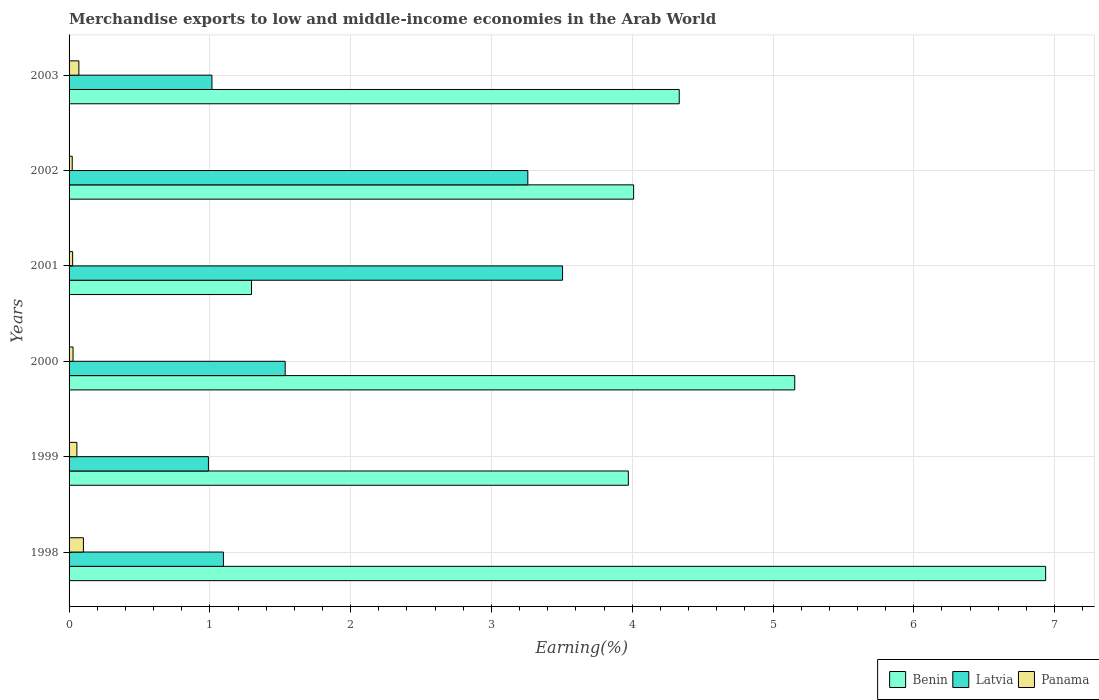Are the number of bars per tick equal to the number of legend labels?
Your answer should be compact. Yes. How many bars are there on the 6th tick from the top?
Offer a very short reply. 3. How many bars are there on the 2nd tick from the bottom?
Keep it short and to the point. 3. In how many cases, is the number of bars for a given year not equal to the number of legend labels?
Offer a terse response. 0. What is the percentage of amount earned from merchandise exports in Latvia in 2003?
Offer a terse response. 1.01. Across all years, what is the maximum percentage of amount earned from merchandise exports in Latvia?
Make the answer very short. 3.51. Across all years, what is the minimum percentage of amount earned from merchandise exports in Latvia?
Your answer should be very brief. 0.99. In which year was the percentage of amount earned from merchandise exports in Benin maximum?
Give a very brief answer. 1998. What is the total percentage of amount earned from merchandise exports in Panama in the graph?
Ensure brevity in your answer.  0.3. What is the difference between the percentage of amount earned from merchandise exports in Latvia in 2000 and that in 2002?
Ensure brevity in your answer.  -1.72. What is the difference between the percentage of amount earned from merchandise exports in Benin in 1999 and the percentage of amount earned from merchandise exports in Panama in 2003?
Ensure brevity in your answer.  3.9. What is the average percentage of amount earned from merchandise exports in Panama per year?
Provide a succinct answer. 0.05. In the year 2002, what is the difference between the percentage of amount earned from merchandise exports in Benin and percentage of amount earned from merchandise exports in Latvia?
Provide a short and direct response. 0.75. In how many years, is the percentage of amount earned from merchandise exports in Latvia greater than 4 %?
Your response must be concise. 0. What is the ratio of the percentage of amount earned from merchandise exports in Benin in 2000 to that in 2001?
Offer a very short reply. 3.98. What is the difference between the highest and the second highest percentage of amount earned from merchandise exports in Benin?
Provide a succinct answer. 1.78. What is the difference between the highest and the lowest percentage of amount earned from merchandise exports in Latvia?
Offer a terse response. 2.52. Is the sum of the percentage of amount earned from merchandise exports in Latvia in 1999 and 2002 greater than the maximum percentage of amount earned from merchandise exports in Benin across all years?
Your answer should be very brief. No. What does the 1st bar from the top in 2003 represents?
Make the answer very short. Panama. What does the 1st bar from the bottom in 2002 represents?
Your answer should be compact. Benin. Is it the case that in every year, the sum of the percentage of amount earned from merchandise exports in Panama and percentage of amount earned from merchandise exports in Benin is greater than the percentage of amount earned from merchandise exports in Latvia?
Your response must be concise. No. How many bars are there?
Make the answer very short. 18. Are all the bars in the graph horizontal?
Offer a terse response. Yes. How many years are there in the graph?
Provide a short and direct response. 6. Where does the legend appear in the graph?
Ensure brevity in your answer.  Bottom right. What is the title of the graph?
Give a very brief answer. Merchandise exports to low and middle-income economies in the Arab World. Does "Madagascar" appear as one of the legend labels in the graph?
Offer a very short reply. No. What is the label or title of the X-axis?
Offer a very short reply. Earning(%). What is the Earning(%) in Benin in 1998?
Your answer should be compact. 6.94. What is the Earning(%) in Latvia in 1998?
Your response must be concise. 1.1. What is the Earning(%) in Panama in 1998?
Ensure brevity in your answer.  0.1. What is the Earning(%) of Benin in 1999?
Provide a short and direct response. 3.97. What is the Earning(%) in Latvia in 1999?
Your answer should be very brief. 0.99. What is the Earning(%) in Panama in 1999?
Offer a terse response. 0.06. What is the Earning(%) in Benin in 2000?
Provide a succinct answer. 5.15. What is the Earning(%) of Latvia in 2000?
Your response must be concise. 1.54. What is the Earning(%) of Panama in 2000?
Make the answer very short. 0.03. What is the Earning(%) of Benin in 2001?
Your answer should be compact. 1.3. What is the Earning(%) in Latvia in 2001?
Provide a succinct answer. 3.51. What is the Earning(%) of Panama in 2001?
Give a very brief answer. 0.03. What is the Earning(%) in Benin in 2002?
Your answer should be very brief. 4.01. What is the Earning(%) of Latvia in 2002?
Provide a succinct answer. 3.26. What is the Earning(%) in Panama in 2002?
Keep it short and to the point. 0.02. What is the Earning(%) in Benin in 2003?
Make the answer very short. 4.33. What is the Earning(%) of Latvia in 2003?
Keep it short and to the point. 1.01. What is the Earning(%) of Panama in 2003?
Your answer should be very brief. 0.07. Across all years, what is the maximum Earning(%) in Benin?
Keep it short and to the point. 6.94. Across all years, what is the maximum Earning(%) in Latvia?
Your response must be concise. 3.51. Across all years, what is the maximum Earning(%) in Panama?
Make the answer very short. 0.1. Across all years, what is the minimum Earning(%) of Benin?
Give a very brief answer. 1.3. Across all years, what is the minimum Earning(%) of Latvia?
Provide a short and direct response. 0.99. Across all years, what is the minimum Earning(%) in Panama?
Make the answer very short. 0.02. What is the total Earning(%) of Benin in the graph?
Ensure brevity in your answer.  25.7. What is the total Earning(%) of Latvia in the graph?
Offer a terse response. 11.4. What is the total Earning(%) in Panama in the graph?
Offer a terse response. 0.3. What is the difference between the Earning(%) in Benin in 1998 and that in 1999?
Your answer should be compact. 2.96. What is the difference between the Earning(%) in Latvia in 1998 and that in 1999?
Ensure brevity in your answer.  0.11. What is the difference between the Earning(%) of Panama in 1998 and that in 1999?
Your answer should be compact. 0.05. What is the difference between the Earning(%) of Benin in 1998 and that in 2000?
Keep it short and to the point. 1.78. What is the difference between the Earning(%) in Latvia in 1998 and that in 2000?
Your answer should be compact. -0.44. What is the difference between the Earning(%) of Panama in 1998 and that in 2000?
Provide a short and direct response. 0.07. What is the difference between the Earning(%) in Benin in 1998 and that in 2001?
Your answer should be very brief. 5.64. What is the difference between the Earning(%) of Latvia in 1998 and that in 2001?
Give a very brief answer. -2.41. What is the difference between the Earning(%) of Panama in 1998 and that in 2001?
Your answer should be very brief. 0.08. What is the difference between the Earning(%) in Benin in 1998 and that in 2002?
Your response must be concise. 2.93. What is the difference between the Earning(%) of Latvia in 1998 and that in 2002?
Offer a terse response. -2.16. What is the difference between the Earning(%) of Panama in 1998 and that in 2002?
Your answer should be very brief. 0.08. What is the difference between the Earning(%) in Benin in 1998 and that in 2003?
Provide a short and direct response. 2.6. What is the difference between the Earning(%) of Latvia in 1998 and that in 2003?
Ensure brevity in your answer.  0.08. What is the difference between the Earning(%) in Panama in 1998 and that in 2003?
Offer a terse response. 0.03. What is the difference between the Earning(%) of Benin in 1999 and that in 2000?
Your response must be concise. -1.18. What is the difference between the Earning(%) in Latvia in 1999 and that in 2000?
Keep it short and to the point. -0.55. What is the difference between the Earning(%) in Panama in 1999 and that in 2000?
Your response must be concise. 0.03. What is the difference between the Earning(%) of Benin in 1999 and that in 2001?
Your answer should be very brief. 2.68. What is the difference between the Earning(%) of Latvia in 1999 and that in 2001?
Keep it short and to the point. -2.52. What is the difference between the Earning(%) in Panama in 1999 and that in 2001?
Provide a succinct answer. 0.03. What is the difference between the Earning(%) of Benin in 1999 and that in 2002?
Provide a succinct answer. -0.04. What is the difference between the Earning(%) in Latvia in 1999 and that in 2002?
Make the answer very short. -2.27. What is the difference between the Earning(%) in Panama in 1999 and that in 2002?
Your answer should be compact. 0.03. What is the difference between the Earning(%) of Benin in 1999 and that in 2003?
Give a very brief answer. -0.36. What is the difference between the Earning(%) in Latvia in 1999 and that in 2003?
Keep it short and to the point. -0.03. What is the difference between the Earning(%) in Panama in 1999 and that in 2003?
Your answer should be very brief. -0.01. What is the difference between the Earning(%) of Benin in 2000 and that in 2001?
Provide a succinct answer. 3.86. What is the difference between the Earning(%) in Latvia in 2000 and that in 2001?
Keep it short and to the point. -1.97. What is the difference between the Earning(%) in Panama in 2000 and that in 2001?
Your answer should be compact. 0. What is the difference between the Earning(%) of Benin in 2000 and that in 2002?
Your answer should be compact. 1.14. What is the difference between the Earning(%) in Latvia in 2000 and that in 2002?
Keep it short and to the point. -1.72. What is the difference between the Earning(%) of Panama in 2000 and that in 2002?
Provide a succinct answer. 0.01. What is the difference between the Earning(%) in Benin in 2000 and that in 2003?
Offer a terse response. 0.82. What is the difference between the Earning(%) of Latvia in 2000 and that in 2003?
Provide a short and direct response. 0.52. What is the difference between the Earning(%) of Panama in 2000 and that in 2003?
Your answer should be very brief. -0.04. What is the difference between the Earning(%) of Benin in 2001 and that in 2002?
Make the answer very short. -2.71. What is the difference between the Earning(%) of Latvia in 2001 and that in 2002?
Your answer should be very brief. 0.25. What is the difference between the Earning(%) of Panama in 2001 and that in 2002?
Keep it short and to the point. 0. What is the difference between the Earning(%) in Benin in 2001 and that in 2003?
Your answer should be very brief. -3.04. What is the difference between the Earning(%) in Latvia in 2001 and that in 2003?
Ensure brevity in your answer.  2.49. What is the difference between the Earning(%) of Panama in 2001 and that in 2003?
Your response must be concise. -0.04. What is the difference between the Earning(%) in Benin in 2002 and that in 2003?
Your response must be concise. -0.32. What is the difference between the Earning(%) of Latvia in 2002 and that in 2003?
Keep it short and to the point. 2.24. What is the difference between the Earning(%) of Panama in 2002 and that in 2003?
Your answer should be very brief. -0.05. What is the difference between the Earning(%) of Benin in 1998 and the Earning(%) of Latvia in 1999?
Provide a succinct answer. 5.95. What is the difference between the Earning(%) in Benin in 1998 and the Earning(%) in Panama in 1999?
Provide a succinct answer. 6.88. What is the difference between the Earning(%) of Latvia in 1998 and the Earning(%) of Panama in 1999?
Provide a short and direct response. 1.04. What is the difference between the Earning(%) of Benin in 1998 and the Earning(%) of Latvia in 2000?
Your response must be concise. 5.4. What is the difference between the Earning(%) in Benin in 1998 and the Earning(%) in Panama in 2000?
Offer a terse response. 6.91. What is the difference between the Earning(%) of Latvia in 1998 and the Earning(%) of Panama in 2000?
Give a very brief answer. 1.07. What is the difference between the Earning(%) in Benin in 1998 and the Earning(%) in Latvia in 2001?
Your response must be concise. 3.43. What is the difference between the Earning(%) in Benin in 1998 and the Earning(%) in Panama in 2001?
Your answer should be very brief. 6.91. What is the difference between the Earning(%) of Latvia in 1998 and the Earning(%) of Panama in 2001?
Provide a short and direct response. 1.07. What is the difference between the Earning(%) of Benin in 1998 and the Earning(%) of Latvia in 2002?
Your answer should be compact. 3.68. What is the difference between the Earning(%) in Benin in 1998 and the Earning(%) in Panama in 2002?
Ensure brevity in your answer.  6.91. What is the difference between the Earning(%) of Latvia in 1998 and the Earning(%) of Panama in 2002?
Keep it short and to the point. 1.07. What is the difference between the Earning(%) of Benin in 1998 and the Earning(%) of Latvia in 2003?
Your answer should be compact. 5.92. What is the difference between the Earning(%) in Benin in 1998 and the Earning(%) in Panama in 2003?
Give a very brief answer. 6.87. What is the difference between the Earning(%) of Latvia in 1998 and the Earning(%) of Panama in 2003?
Ensure brevity in your answer.  1.03. What is the difference between the Earning(%) in Benin in 1999 and the Earning(%) in Latvia in 2000?
Provide a short and direct response. 2.44. What is the difference between the Earning(%) in Benin in 1999 and the Earning(%) in Panama in 2000?
Offer a very short reply. 3.94. What is the difference between the Earning(%) of Latvia in 1999 and the Earning(%) of Panama in 2000?
Keep it short and to the point. 0.96. What is the difference between the Earning(%) in Benin in 1999 and the Earning(%) in Latvia in 2001?
Offer a terse response. 0.47. What is the difference between the Earning(%) of Benin in 1999 and the Earning(%) of Panama in 2001?
Make the answer very short. 3.95. What is the difference between the Earning(%) in Benin in 1999 and the Earning(%) in Latvia in 2002?
Your response must be concise. 0.71. What is the difference between the Earning(%) of Benin in 1999 and the Earning(%) of Panama in 2002?
Provide a short and direct response. 3.95. What is the difference between the Earning(%) in Latvia in 1999 and the Earning(%) in Panama in 2002?
Provide a succinct answer. 0.97. What is the difference between the Earning(%) in Benin in 1999 and the Earning(%) in Latvia in 2003?
Offer a very short reply. 2.96. What is the difference between the Earning(%) in Benin in 1999 and the Earning(%) in Panama in 2003?
Give a very brief answer. 3.9. What is the difference between the Earning(%) of Latvia in 1999 and the Earning(%) of Panama in 2003?
Ensure brevity in your answer.  0.92. What is the difference between the Earning(%) of Benin in 2000 and the Earning(%) of Latvia in 2001?
Ensure brevity in your answer.  1.65. What is the difference between the Earning(%) of Benin in 2000 and the Earning(%) of Panama in 2001?
Offer a very short reply. 5.13. What is the difference between the Earning(%) in Latvia in 2000 and the Earning(%) in Panama in 2001?
Keep it short and to the point. 1.51. What is the difference between the Earning(%) in Benin in 2000 and the Earning(%) in Latvia in 2002?
Keep it short and to the point. 1.9. What is the difference between the Earning(%) in Benin in 2000 and the Earning(%) in Panama in 2002?
Your response must be concise. 5.13. What is the difference between the Earning(%) of Latvia in 2000 and the Earning(%) of Panama in 2002?
Provide a succinct answer. 1.51. What is the difference between the Earning(%) of Benin in 2000 and the Earning(%) of Latvia in 2003?
Your answer should be very brief. 4.14. What is the difference between the Earning(%) of Benin in 2000 and the Earning(%) of Panama in 2003?
Your answer should be compact. 5.08. What is the difference between the Earning(%) of Latvia in 2000 and the Earning(%) of Panama in 2003?
Make the answer very short. 1.47. What is the difference between the Earning(%) of Benin in 2001 and the Earning(%) of Latvia in 2002?
Give a very brief answer. -1.96. What is the difference between the Earning(%) of Benin in 2001 and the Earning(%) of Panama in 2002?
Offer a very short reply. 1.27. What is the difference between the Earning(%) of Latvia in 2001 and the Earning(%) of Panama in 2002?
Make the answer very short. 3.48. What is the difference between the Earning(%) in Benin in 2001 and the Earning(%) in Latvia in 2003?
Offer a terse response. 0.28. What is the difference between the Earning(%) in Benin in 2001 and the Earning(%) in Panama in 2003?
Provide a succinct answer. 1.23. What is the difference between the Earning(%) in Latvia in 2001 and the Earning(%) in Panama in 2003?
Provide a succinct answer. 3.44. What is the difference between the Earning(%) in Benin in 2002 and the Earning(%) in Latvia in 2003?
Provide a succinct answer. 3. What is the difference between the Earning(%) of Benin in 2002 and the Earning(%) of Panama in 2003?
Make the answer very short. 3.94. What is the difference between the Earning(%) in Latvia in 2002 and the Earning(%) in Panama in 2003?
Provide a succinct answer. 3.19. What is the average Earning(%) of Benin per year?
Offer a very short reply. 4.28. What is the average Earning(%) of Latvia per year?
Your response must be concise. 1.9. What is the average Earning(%) of Panama per year?
Make the answer very short. 0.05. In the year 1998, what is the difference between the Earning(%) in Benin and Earning(%) in Latvia?
Provide a succinct answer. 5.84. In the year 1998, what is the difference between the Earning(%) in Benin and Earning(%) in Panama?
Provide a short and direct response. 6.83. In the year 1998, what is the difference between the Earning(%) of Latvia and Earning(%) of Panama?
Your answer should be very brief. 0.99. In the year 1999, what is the difference between the Earning(%) of Benin and Earning(%) of Latvia?
Keep it short and to the point. 2.98. In the year 1999, what is the difference between the Earning(%) of Benin and Earning(%) of Panama?
Your answer should be very brief. 3.92. In the year 1999, what is the difference between the Earning(%) in Latvia and Earning(%) in Panama?
Make the answer very short. 0.93. In the year 2000, what is the difference between the Earning(%) of Benin and Earning(%) of Latvia?
Give a very brief answer. 3.62. In the year 2000, what is the difference between the Earning(%) of Benin and Earning(%) of Panama?
Your answer should be compact. 5.13. In the year 2000, what is the difference between the Earning(%) of Latvia and Earning(%) of Panama?
Ensure brevity in your answer.  1.51. In the year 2001, what is the difference between the Earning(%) of Benin and Earning(%) of Latvia?
Make the answer very short. -2.21. In the year 2001, what is the difference between the Earning(%) of Benin and Earning(%) of Panama?
Ensure brevity in your answer.  1.27. In the year 2001, what is the difference between the Earning(%) in Latvia and Earning(%) in Panama?
Your answer should be compact. 3.48. In the year 2002, what is the difference between the Earning(%) in Benin and Earning(%) in Latvia?
Offer a very short reply. 0.75. In the year 2002, what is the difference between the Earning(%) in Benin and Earning(%) in Panama?
Your answer should be very brief. 3.99. In the year 2002, what is the difference between the Earning(%) in Latvia and Earning(%) in Panama?
Provide a succinct answer. 3.24. In the year 2003, what is the difference between the Earning(%) in Benin and Earning(%) in Latvia?
Offer a terse response. 3.32. In the year 2003, what is the difference between the Earning(%) in Benin and Earning(%) in Panama?
Provide a succinct answer. 4.26. In the year 2003, what is the difference between the Earning(%) of Latvia and Earning(%) of Panama?
Make the answer very short. 0.95. What is the ratio of the Earning(%) of Benin in 1998 to that in 1999?
Offer a very short reply. 1.75. What is the ratio of the Earning(%) in Latvia in 1998 to that in 1999?
Provide a succinct answer. 1.11. What is the ratio of the Earning(%) in Panama in 1998 to that in 1999?
Provide a short and direct response. 1.84. What is the ratio of the Earning(%) in Benin in 1998 to that in 2000?
Keep it short and to the point. 1.35. What is the ratio of the Earning(%) of Latvia in 1998 to that in 2000?
Provide a short and direct response. 0.71. What is the ratio of the Earning(%) of Panama in 1998 to that in 2000?
Offer a terse response. 3.61. What is the ratio of the Earning(%) of Benin in 1998 to that in 2001?
Provide a succinct answer. 5.35. What is the ratio of the Earning(%) of Latvia in 1998 to that in 2001?
Offer a very short reply. 0.31. What is the ratio of the Earning(%) of Panama in 1998 to that in 2001?
Give a very brief answer. 4.01. What is the ratio of the Earning(%) of Benin in 1998 to that in 2002?
Provide a short and direct response. 1.73. What is the ratio of the Earning(%) in Latvia in 1998 to that in 2002?
Offer a very short reply. 0.34. What is the ratio of the Earning(%) in Panama in 1998 to that in 2002?
Your answer should be very brief. 4.54. What is the ratio of the Earning(%) in Benin in 1998 to that in 2003?
Keep it short and to the point. 1.6. What is the ratio of the Earning(%) of Latvia in 1998 to that in 2003?
Keep it short and to the point. 1.08. What is the ratio of the Earning(%) of Panama in 1998 to that in 2003?
Give a very brief answer. 1.46. What is the ratio of the Earning(%) in Benin in 1999 to that in 2000?
Offer a terse response. 0.77. What is the ratio of the Earning(%) in Latvia in 1999 to that in 2000?
Provide a short and direct response. 0.64. What is the ratio of the Earning(%) of Panama in 1999 to that in 2000?
Give a very brief answer. 1.97. What is the ratio of the Earning(%) of Benin in 1999 to that in 2001?
Provide a short and direct response. 3.07. What is the ratio of the Earning(%) of Latvia in 1999 to that in 2001?
Ensure brevity in your answer.  0.28. What is the ratio of the Earning(%) in Panama in 1999 to that in 2001?
Your response must be concise. 2.19. What is the ratio of the Earning(%) in Benin in 1999 to that in 2002?
Give a very brief answer. 0.99. What is the ratio of the Earning(%) of Latvia in 1999 to that in 2002?
Give a very brief answer. 0.3. What is the ratio of the Earning(%) in Panama in 1999 to that in 2002?
Provide a short and direct response. 2.47. What is the ratio of the Earning(%) in Benin in 1999 to that in 2003?
Your response must be concise. 0.92. What is the ratio of the Earning(%) of Latvia in 1999 to that in 2003?
Offer a very short reply. 0.98. What is the ratio of the Earning(%) of Panama in 1999 to that in 2003?
Offer a terse response. 0.8. What is the ratio of the Earning(%) of Benin in 2000 to that in 2001?
Provide a short and direct response. 3.98. What is the ratio of the Earning(%) of Latvia in 2000 to that in 2001?
Offer a terse response. 0.44. What is the ratio of the Earning(%) of Panama in 2000 to that in 2001?
Keep it short and to the point. 1.11. What is the ratio of the Earning(%) in Benin in 2000 to that in 2002?
Make the answer very short. 1.29. What is the ratio of the Earning(%) of Latvia in 2000 to that in 2002?
Ensure brevity in your answer.  0.47. What is the ratio of the Earning(%) of Panama in 2000 to that in 2002?
Your answer should be very brief. 1.26. What is the ratio of the Earning(%) of Benin in 2000 to that in 2003?
Make the answer very short. 1.19. What is the ratio of the Earning(%) in Latvia in 2000 to that in 2003?
Make the answer very short. 1.51. What is the ratio of the Earning(%) of Panama in 2000 to that in 2003?
Provide a succinct answer. 0.41. What is the ratio of the Earning(%) in Benin in 2001 to that in 2002?
Your answer should be very brief. 0.32. What is the ratio of the Earning(%) in Latvia in 2001 to that in 2002?
Your answer should be very brief. 1.08. What is the ratio of the Earning(%) in Panama in 2001 to that in 2002?
Provide a succinct answer. 1.13. What is the ratio of the Earning(%) in Benin in 2001 to that in 2003?
Your response must be concise. 0.3. What is the ratio of the Earning(%) in Latvia in 2001 to that in 2003?
Your response must be concise. 3.45. What is the ratio of the Earning(%) in Panama in 2001 to that in 2003?
Offer a terse response. 0.36. What is the ratio of the Earning(%) in Benin in 2002 to that in 2003?
Your answer should be compact. 0.93. What is the ratio of the Earning(%) in Latvia in 2002 to that in 2003?
Your answer should be very brief. 3.21. What is the ratio of the Earning(%) of Panama in 2002 to that in 2003?
Make the answer very short. 0.32. What is the difference between the highest and the second highest Earning(%) of Benin?
Ensure brevity in your answer.  1.78. What is the difference between the highest and the second highest Earning(%) of Latvia?
Offer a very short reply. 0.25. What is the difference between the highest and the second highest Earning(%) of Panama?
Ensure brevity in your answer.  0.03. What is the difference between the highest and the lowest Earning(%) in Benin?
Your answer should be compact. 5.64. What is the difference between the highest and the lowest Earning(%) in Latvia?
Offer a terse response. 2.52. What is the difference between the highest and the lowest Earning(%) of Panama?
Provide a short and direct response. 0.08. 